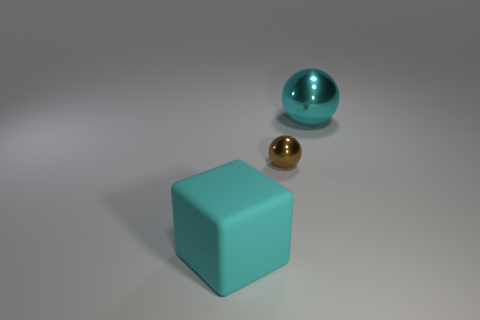What is the sphere that is on the right side of the brown ball made of?
Your answer should be compact. Metal. There is a large object that is behind the big cyan rubber cube; is it the same color as the object to the left of the brown sphere?
Make the answer very short. Yes. There is a matte thing that is the same size as the cyan shiny ball; what is its color?
Provide a succinct answer. Cyan. What number of other things are the same shape as the rubber object?
Keep it short and to the point. 0. There is a metal ball that is in front of the cyan shiny ball; what size is it?
Ensure brevity in your answer.  Small. What number of matte cubes are right of the thing that is on the right side of the brown ball?
Your answer should be compact. 0. What number of other objects are there of the same size as the block?
Provide a short and direct response. 1. Is the color of the rubber thing the same as the tiny thing?
Provide a succinct answer. No. Does the cyan thing that is behind the large matte block have the same shape as the cyan rubber object?
Ensure brevity in your answer.  No. How many large things are behind the brown metallic object and in front of the small object?
Provide a succinct answer. 0. 